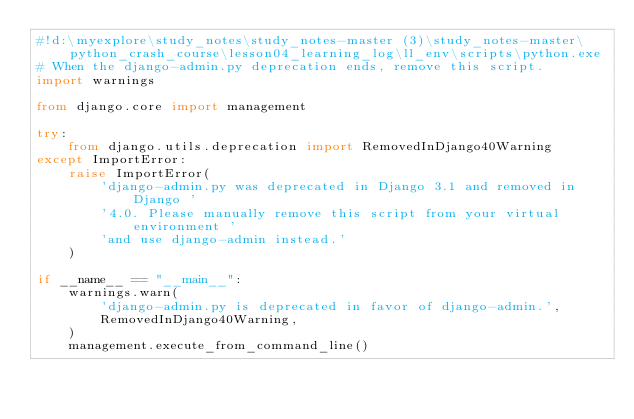<code> <loc_0><loc_0><loc_500><loc_500><_Python_>#!d:\myexplore\study_notes\study_notes-master (3)\study_notes-master\python_crash_course\lesson04_learning_log\ll_env\scripts\python.exe
# When the django-admin.py deprecation ends, remove this script.
import warnings

from django.core import management

try:
    from django.utils.deprecation import RemovedInDjango40Warning
except ImportError:
    raise ImportError(
        'django-admin.py was deprecated in Django 3.1 and removed in Django '
        '4.0. Please manually remove this script from your virtual environment '
        'and use django-admin instead.'
    )

if __name__ == "__main__":
    warnings.warn(
        'django-admin.py is deprecated in favor of django-admin.',
        RemovedInDjango40Warning,
    )
    management.execute_from_command_line()
</code> 